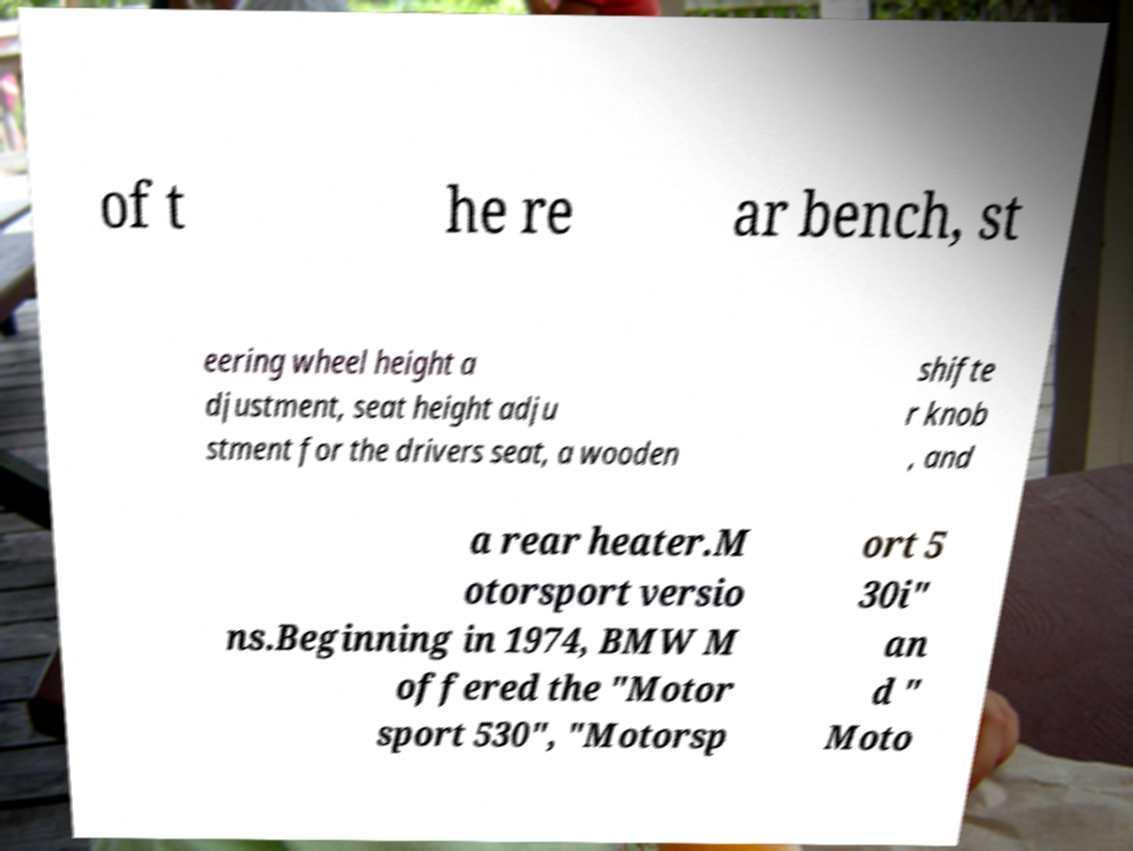Can you read and provide the text displayed in the image?This photo seems to have some interesting text. Can you extract and type it out for me? of t he re ar bench, st eering wheel height a djustment, seat height adju stment for the drivers seat, a wooden shifte r knob , and a rear heater.M otorsport versio ns.Beginning in 1974, BMW M offered the "Motor sport 530", "Motorsp ort 5 30i" an d " Moto 